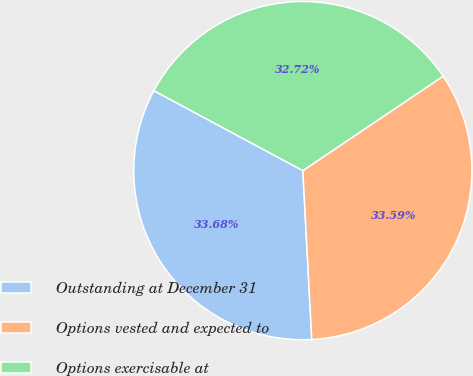Convert chart to OTSL. <chart><loc_0><loc_0><loc_500><loc_500><pie_chart><fcel>Outstanding at December 31<fcel>Options vested and expected to<fcel>Options exercisable at<nl><fcel>33.68%<fcel>33.59%<fcel>32.72%<nl></chart> 